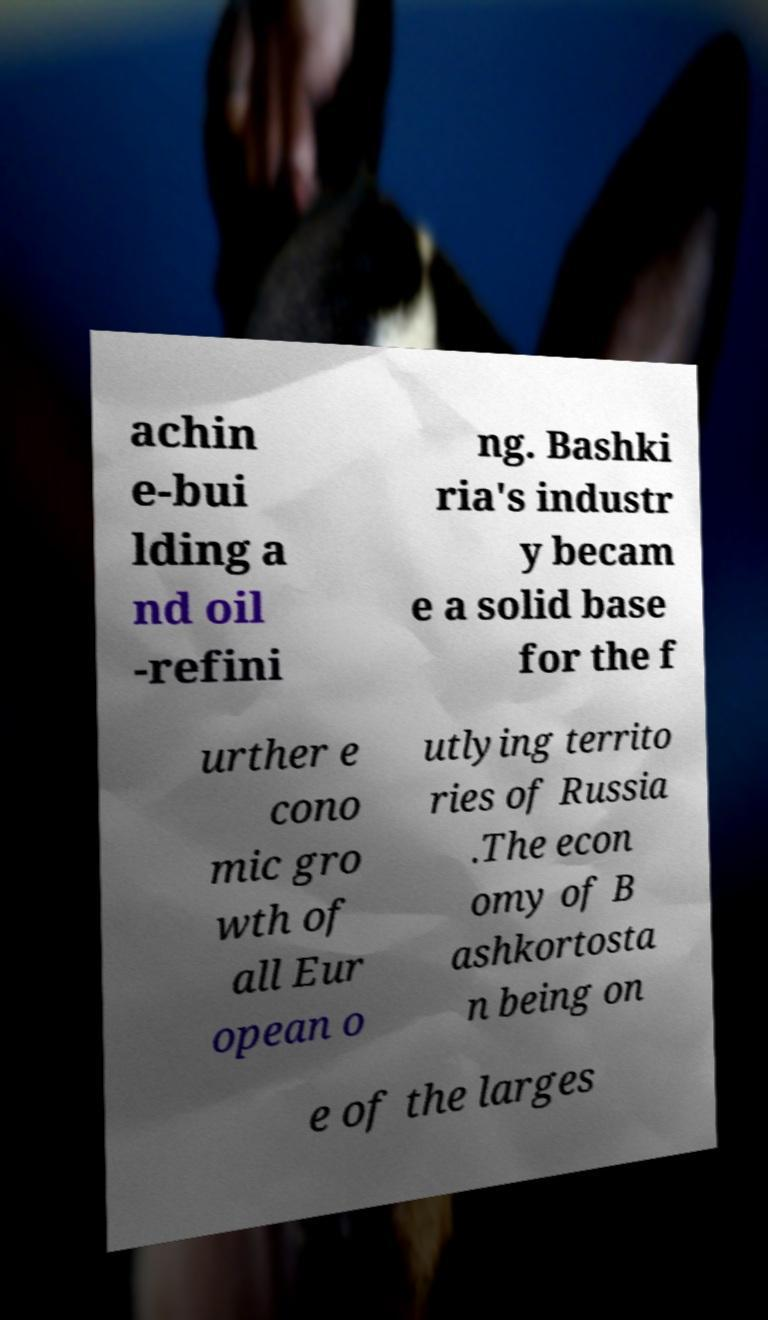Can you accurately transcribe the text from the provided image for me? achin e-bui lding a nd oil -refini ng. Bashki ria's industr y becam e a solid base for the f urther e cono mic gro wth of all Eur opean o utlying territo ries of Russia .The econ omy of B ashkortosta n being on e of the larges 